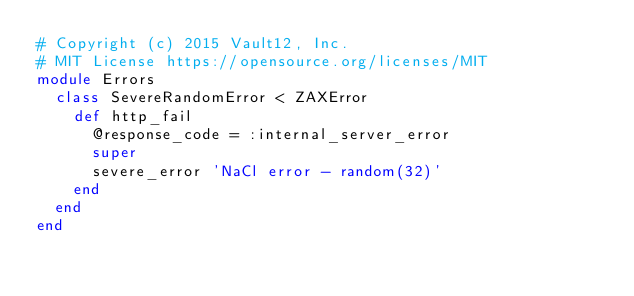<code> <loc_0><loc_0><loc_500><loc_500><_Ruby_># Copyright (c) 2015 Vault12, Inc.
# MIT License https://opensource.org/licenses/MIT
module Errors
  class SevereRandomError < ZAXError
    def http_fail
      @response_code = :internal_server_error
      super
      severe_error 'NaCl error - random(32)'
    end
  end
end
</code> 